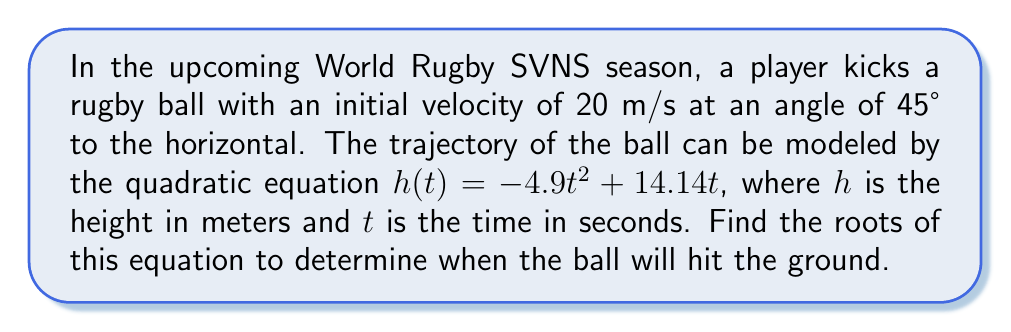Give your solution to this math problem. To find the roots of the quadratic equation, we need to solve $h(t) = 0$:

1) Set up the equation:
   $-4.9t^2 + 14.14t = 0$

2) Factor out the greatest common factor:
   $t(-4.9t + 14.14) = 0$

3) Use the zero product property. Either $t = 0$ or $-4.9t + 14.14 = 0$

4) Solve the linear equation:
   $-4.9t + 14.14 = 0$
   $-4.9t = -14.14$
   $t = \frac{14.14}{4.9} \approx 2.89$

5) Therefore, the roots are $t = 0$ and $t \approx 2.89$

6) Interpret the results:
   - $t = 0$ represents the moment the ball is kicked
   - $t \approx 2.89$ represents when the ball hits the ground, about 2.89 seconds after being kicked
Answer: $t = 0$ and $t \approx 2.89$ seconds 